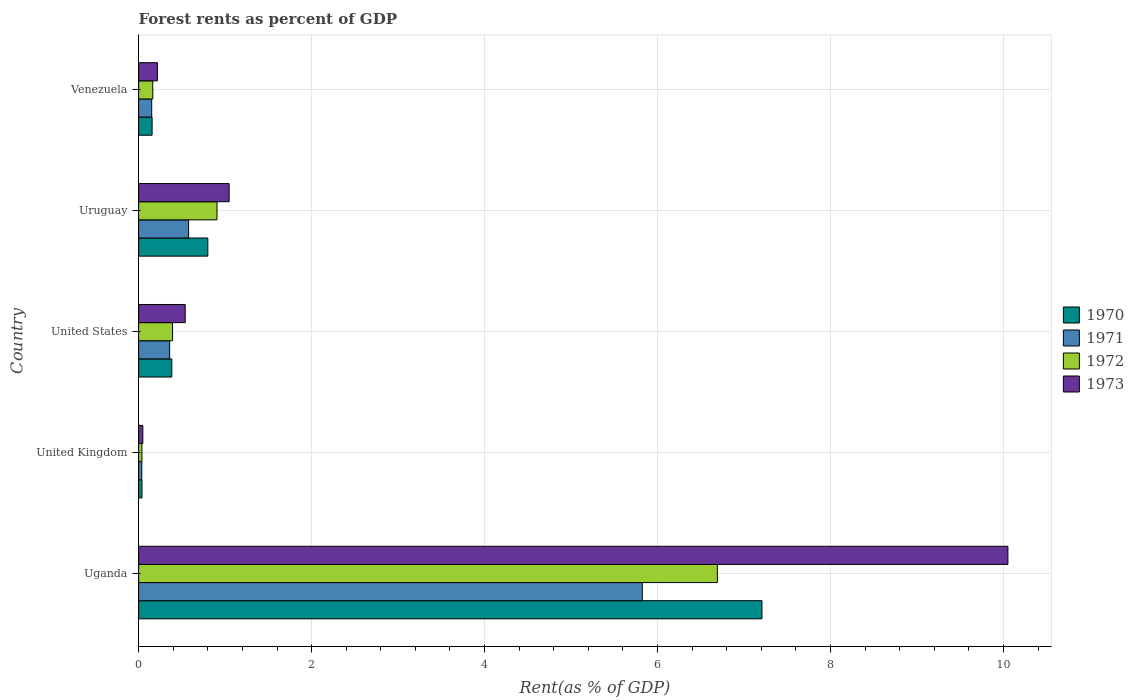How many different coloured bars are there?
Give a very brief answer. 4. Are the number of bars per tick equal to the number of legend labels?
Make the answer very short. Yes. How many bars are there on the 4th tick from the top?
Your response must be concise. 4. What is the label of the 1st group of bars from the top?
Offer a very short reply. Venezuela. What is the forest rent in 1972 in Uganda?
Your answer should be very brief. 6.69. Across all countries, what is the maximum forest rent in 1971?
Provide a short and direct response. 5.82. Across all countries, what is the minimum forest rent in 1970?
Keep it short and to the point. 0.04. In which country was the forest rent in 1973 maximum?
Your answer should be very brief. Uganda. What is the total forest rent in 1973 in the graph?
Provide a short and direct response. 11.9. What is the difference between the forest rent in 1972 in Uganda and that in Venezuela?
Offer a terse response. 6.53. What is the difference between the forest rent in 1970 in United Kingdom and the forest rent in 1971 in Uruguay?
Offer a very short reply. -0.54. What is the average forest rent in 1972 per country?
Your answer should be very brief. 1.64. What is the difference between the forest rent in 1973 and forest rent in 1970 in Uruguay?
Provide a succinct answer. 0.25. In how many countries, is the forest rent in 1970 greater than 8.4 %?
Your answer should be very brief. 0. What is the ratio of the forest rent in 1971 in United States to that in Uruguay?
Keep it short and to the point. 0.62. Is the difference between the forest rent in 1973 in Uruguay and Venezuela greater than the difference between the forest rent in 1970 in Uruguay and Venezuela?
Your response must be concise. Yes. What is the difference between the highest and the second highest forest rent in 1971?
Provide a succinct answer. 5.25. What is the difference between the highest and the lowest forest rent in 1971?
Offer a very short reply. 5.79. In how many countries, is the forest rent in 1970 greater than the average forest rent in 1970 taken over all countries?
Keep it short and to the point. 1. Is the sum of the forest rent in 1971 in United Kingdom and United States greater than the maximum forest rent in 1973 across all countries?
Ensure brevity in your answer.  No. What does the 1st bar from the top in Uruguay represents?
Offer a very short reply. 1973. What does the 1st bar from the bottom in Uganda represents?
Provide a succinct answer. 1970. How many countries are there in the graph?
Provide a short and direct response. 5. What is the difference between two consecutive major ticks on the X-axis?
Your answer should be very brief. 2. Does the graph contain any zero values?
Your answer should be compact. No. Where does the legend appear in the graph?
Ensure brevity in your answer.  Center right. How are the legend labels stacked?
Make the answer very short. Vertical. What is the title of the graph?
Ensure brevity in your answer.  Forest rents as percent of GDP. Does "1970" appear as one of the legend labels in the graph?
Provide a short and direct response. Yes. What is the label or title of the X-axis?
Make the answer very short. Rent(as % of GDP). What is the Rent(as % of GDP) of 1970 in Uganda?
Keep it short and to the point. 7.21. What is the Rent(as % of GDP) of 1971 in Uganda?
Provide a succinct answer. 5.82. What is the Rent(as % of GDP) of 1972 in Uganda?
Your response must be concise. 6.69. What is the Rent(as % of GDP) in 1973 in Uganda?
Provide a short and direct response. 10.05. What is the Rent(as % of GDP) in 1970 in United Kingdom?
Keep it short and to the point. 0.04. What is the Rent(as % of GDP) of 1971 in United Kingdom?
Provide a short and direct response. 0.04. What is the Rent(as % of GDP) in 1972 in United Kingdom?
Make the answer very short. 0.04. What is the Rent(as % of GDP) in 1973 in United Kingdom?
Your answer should be very brief. 0.05. What is the Rent(as % of GDP) in 1970 in United States?
Your answer should be compact. 0.38. What is the Rent(as % of GDP) in 1971 in United States?
Your answer should be very brief. 0.36. What is the Rent(as % of GDP) of 1972 in United States?
Ensure brevity in your answer.  0.39. What is the Rent(as % of GDP) in 1973 in United States?
Provide a succinct answer. 0.54. What is the Rent(as % of GDP) of 1970 in Uruguay?
Provide a succinct answer. 0.8. What is the Rent(as % of GDP) in 1971 in Uruguay?
Your answer should be very brief. 0.58. What is the Rent(as % of GDP) of 1972 in Uruguay?
Give a very brief answer. 0.91. What is the Rent(as % of GDP) in 1973 in Uruguay?
Your answer should be compact. 1.05. What is the Rent(as % of GDP) in 1970 in Venezuela?
Make the answer very short. 0.16. What is the Rent(as % of GDP) in 1971 in Venezuela?
Provide a short and direct response. 0.15. What is the Rent(as % of GDP) of 1972 in Venezuela?
Provide a short and direct response. 0.16. What is the Rent(as % of GDP) of 1973 in Venezuela?
Make the answer very short. 0.22. Across all countries, what is the maximum Rent(as % of GDP) of 1970?
Make the answer very short. 7.21. Across all countries, what is the maximum Rent(as % of GDP) in 1971?
Offer a terse response. 5.82. Across all countries, what is the maximum Rent(as % of GDP) in 1972?
Give a very brief answer. 6.69. Across all countries, what is the maximum Rent(as % of GDP) in 1973?
Your answer should be very brief. 10.05. Across all countries, what is the minimum Rent(as % of GDP) of 1970?
Offer a terse response. 0.04. Across all countries, what is the minimum Rent(as % of GDP) in 1971?
Your response must be concise. 0.04. Across all countries, what is the minimum Rent(as % of GDP) of 1972?
Your response must be concise. 0.04. Across all countries, what is the minimum Rent(as % of GDP) in 1973?
Ensure brevity in your answer.  0.05. What is the total Rent(as % of GDP) in 1970 in the graph?
Your answer should be very brief. 8.59. What is the total Rent(as % of GDP) in 1971 in the graph?
Provide a short and direct response. 6.95. What is the total Rent(as % of GDP) in 1972 in the graph?
Offer a terse response. 8.19. What is the total Rent(as % of GDP) in 1973 in the graph?
Provide a succinct answer. 11.9. What is the difference between the Rent(as % of GDP) in 1970 in Uganda and that in United Kingdom?
Your answer should be compact. 7.17. What is the difference between the Rent(as % of GDP) in 1971 in Uganda and that in United Kingdom?
Keep it short and to the point. 5.79. What is the difference between the Rent(as % of GDP) in 1972 in Uganda and that in United Kingdom?
Provide a succinct answer. 6.65. What is the difference between the Rent(as % of GDP) of 1973 in Uganda and that in United Kingdom?
Your response must be concise. 10. What is the difference between the Rent(as % of GDP) of 1970 in Uganda and that in United States?
Your response must be concise. 6.82. What is the difference between the Rent(as % of GDP) in 1971 in Uganda and that in United States?
Your answer should be very brief. 5.47. What is the difference between the Rent(as % of GDP) of 1972 in Uganda and that in United States?
Your response must be concise. 6.3. What is the difference between the Rent(as % of GDP) in 1973 in Uganda and that in United States?
Offer a very short reply. 9.51. What is the difference between the Rent(as % of GDP) of 1970 in Uganda and that in Uruguay?
Your answer should be very brief. 6.41. What is the difference between the Rent(as % of GDP) in 1971 in Uganda and that in Uruguay?
Ensure brevity in your answer.  5.25. What is the difference between the Rent(as % of GDP) of 1972 in Uganda and that in Uruguay?
Offer a very short reply. 5.79. What is the difference between the Rent(as % of GDP) of 1973 in Uganda and that in Uruguay?
Offer a very short reply. 9. What is the difference between the Rent(as % of GDP) of 1970 in Uganda and that in Venezuela?
Provide a short and direct response. 7.05. What is the difference between the Rent(as % of GDP) in 1971 in Uganda and that in Venezuela?
Provide a short and direct response. 5.67. What is the difference between the Rent(as % of GDP) in 1972 in Uganda and that in Venezuela?
Give a very brief answer. 6.53. What is the difference between the Rent(as % of GDP) of 1973 in Uganda and that in Venezuela?
Keep it short and to the point. 9.83. What is the difference between the Rent(as % of GDP) in 1970 in United Kingdom and that in United States?
Your answer should be compact. -0.34. What is the difference between the Rent(as % of GDP) in 1971 in United Kingdom and that in United States?
Your answer should be very brief. -0.32. What is the difference between the Rent(as % of GDP) in 1972 in United Kingdom and that in United States?
Give a very brief answer. -0.35. What is the difference between the Rent(as % of GDP) in 1973 in United Kingdom and that in United States?
Keep it short and to the point. -0.49. What is the difference between the Rent(as % of GDP) in 1970 in United Kingdom and that in Uruguay?
Ensure brevity in your answer.  -0.76. What is the difference between the Rent(as % of GDP) of 1971 in United Kingdom and that in Uruguay?
Make the answer very short. -0.54. What is the difference between the Rent(as % of GDP) in 1972 in United Kingdom and that in Uruguay?
Offer a terse response. -0.87. What is the difference between the Rent(as % of GDP) in 1973 in United Kingdom and that in Uruguay?
Offer a very short reply. -1. What is the difference between the Rent(as % of GDP) in 1970 in United Kingdom and that in Venezuela?
Offer a very short reply. -0.12. What is the difference between the Rent(as % of GDP) of 1971 in United Kingdom and that in Venezuela?
Ensure brevity in your answer.  -0.11. What is the difference between the Rent(as % of GDP) of 1972 in United Kingdom and that in Venezuela?
Your answer should be very brief. -0.13. What is the difference between the Rent(as % of GDP) of 1973 in United Kingdom and that in Venezuela?
Offer a terse response. -0.17. What is the difference between the Rent(as % of GDP) of 1970 in United States and that in Uruguay?
Ensure brevity in your answer.  -0.42. What is the difference between the Rent(as % of GDP) of 1971 in United States and that in Uruguay?
Your answer should be compact. -0.22. What is the difference between the Rent(as % of GDP) of 1972 in United States and that in Uruguay?
Give a very brief answer. -0.51. What is the difference between the Rent(as % of GDP) of 1973 in United States and that in Uruguay?
Ensure brevity in your answer.  -0.51. What is the difference between the Rent(as % of GDP) of 1970 in United States and that in Venezuela?
Keep it short and to the point. 0.23. What is the difference between the Rent(as % of GDP) of 1971 in United States and that in Venezuela?
Your answer should be compact. 0.21. What is the difference between the Rent(as % of GDP) of 1972 in United States and that in Venezuela?
Provide a short and direct response. 0.23. What is the difference between the Rent(as % of GDP) in 1973 in United States and that in Venezuela?
Your response must be concise. 0.32. What is the difference between the Rent(as % of GDP) of 1970 in Uruguay and that in Venezuela?
Your answer should be very brief. 0.64. What is the difference between the Rent(as % of GDP) in 1971 in Uruguay and that in Venezuela?
Your answer should be compact. 0.43. What is the difference between the Rent(as % of GDP) of 1972 in Uruguay and that in Venezuela?
Give a very brief answer. 0.74. What is the difference between the Rent(as % of GDP) of 1973 in Uruguay and that in Venezuela?
Offer a very short reply. 0.83. What is the difference between the Rent(as % of GDP) in 1970 in Uganda and the Rent(as % of GDP) in 1971 in United Kingdom?
Give a very brief answer. 7.17. What is the difference between the Rent(as % of GDP) in 1970 in Uganda and the Rent(as % of GDP) in 1972 in United Kingdom?
Provide a succinct answer. 7.17. What is the difference between the Rent(as % of GDP) of 1970 in Uganda and the Rent(as % of GDP) of 1973 in United Kingdom?
Make the answer very short. 7.16. What is the difference between the Rent(as % of GDP) of 1971 in Uganda and the Rent(as % of GDP) of 1972 in United Kingdom?
Ensure brevity in your answer.  5.79. What is the difference between the Rent(as % of GDP) of 1971 in Uganda and the Rent(as % of GDP) of 1973 in United Kingdom?
Give a very brief answer. 5.78. What is the difference between the Rent(as % of GDP) of 1972 in Uganda and the Rent(as % of GDP) of 1973 in United Kingdom?
Offer a very short reply. 6.64. What is the difference between the Rent(as % of GDP) of 1970 in Uganda and the Rent(as % of GDP) of 1971 in United States?
Provide a succinct answer. 6.85. What is the difference between the Rent(as % of GDP) of 1970 in Uganda and the Rent(as % of GDP) of 1972 in United States?
Provide a succinct answer. 6.81. What is the difference between the Rent(as % of GDP) of 1970 in Uganda and the Rent(as % of GDP) of 1973 in United States?
Provide a succinct answer. 6.67. What is the difference between the Rent(as % of GDP) of 1971 in Uganda and the Rent(as % of GDP) of 1972 in United States?
Keep it short and to the point. 5.43. What is the difference between the Rent(as % of GDP) in 1971 in Uganda and the Rent(as % of GDP) in 1973 in United States?
Ensure brevity in your answer.  5.29. What is the difference between the Rent(as % of GDP) of 1972 in Uganda and the Rent(as % of GDP) of 1973 in United States?
Provide a short and direct response. 6.15. What is the difference between the Rent(as % of GDP) in 1970 in Uganda and the Rent(as % of GDP) in 1971 in Uruguay?
Give a very brief answer. 6.63. What is the difference between the Rent(as % of GDP) in 1970 in Uganda and the Rent(as % of GDP) in 1972 in Uruguay?
Your answer should be very brief. 6.3. What is the difference between the Rent(as % of GDP) of 1970 in Uganda and the Rent(as % of GDP) of 1973 in Uruguay?
Give a very brief answer. 6.16. What is the difference between the Rent(as % of GDP) in 1971 in Uganda and the Rent(as % of GDP) in 1972 in Uruguay?
Your answer should be very brief. 4.92. What is the difference between the Rent(as % of GDP) in 1971 in Uganda and the Rent(as % of GDP) in 1973 in Uruguay?
Keep it short and to the point. 4.78. What is the difference between the Rent(as % of GDP) of 1972 in Uganda and the Rent(as % of GDP) of 1973 in Uruguay?
Your answer should be compact. 5.65. What is the difference between the Rent(as % of GDP) of 1970 in Uganda and the Rent(as % of GDP) of 1971 in Venezuela?
Your answer should be compact. 7.06. What is the difference between the Rent(as % of GDP) of 1970 in Uganda and the Rent(as % of GDP) of 1972 in Venezuela?
Your answer should be very brief. 7.04. What is the difference between the Rent(as % of GDP) in 1970 in Uganda and the Rent(as % of GDP) in 1973 in Venezuela?
Ensure brevity in your answer.  6.99. What is the difference between the Rent(as % of GDP) of 1971 in Uganda and the Rent(as % of GDP) of 1972 in Venezuela?
Ensure brevity in your answer.  5.66. What is the difference between the Rent(as % of GDP) of 1971 in Uganda and the Rent(as % of GDP) of 1973 in Venezuela?
Keep it short and to the point. 5.61. What is the difference between the Rent(as % of GDP) in 1972 in Uganda and the Rent(as % of GDP) in 1973 in Venezuela?
Give a very brief answer. 6.47. What is the difference between the Rent(as % of GDP) of 1970 in United Kingdom and the Rent(as % of GDP) of 1971 in United States?
Ensure brevity in your answer.  -0.32. What is the difference between the Rent(as % of GDP) of 1970 in United Kingdom and the Rent(as % of GDP) of 1972 in United States?
Make the answer very short. -0.35. What is the difference between the Rent(as % of GDP) of 1970 in United Kingdom and the Rent(as % of GDP) of 1973 in United States?
Your response must be concise. -0.5. What is the difference between the Rent(as % of GDP) in 1971 in United Kingdom and the Rent(as % of GDP) in 1972 in United States?
Your answer should be compact. -0.36. What is the difference between the Rent(as % of GDP) of 1971 in United Kingdom and the Rent(as % of GDP) of 1973 in United States?
Provide a succinct answer. -0.5. What is the difference between the Rent(as % of GDP) in 1972 in United Kingdom and the Rent(as % of GDP) in 1973 in United States?
Provide a succinct answer. -0.5. What is the difference between the Rent(as % of GDP) of 1970 in United Kingdom and the Rent(as % of GDP) of 1971 in Uruguay?
Offer a terse response. -0.54. What is the difference between the Rent(as % of GDP) in 1970 in United Kingdom and the Rent(as % of GDP) in 1972 in Uruguay?
Your response must be concise. -0.87. What is the difference between the Rent(as % of GDP) in 1970 in United Kingdom and the Rent(as % of GDP) in 1973 in Uruguay?
Offer a very short reply. -1.01. What is the difference between the Rent(as % of GDP) in 1971 in United Kingdom and the Rent(as % of GDP) in 1972 in Uruguay?
Your answer should be very brief. -0.87. What is the difference between the Rent(as % of GDP) in 1971 in United Kingdom and the Rent(as % of GDP) in 1973 in Uruguay?
Give a very brief answer. -1.01. What is the difference between the Rent(as % of GDP) in 1972 in United Kingdom and the Rent(as % of GDP) in 1973 in Uruguay?
Provide a short and direct response. -1.01. What is the difference between the Rent(as % of GDP) in 1970 in United Kingdom and the Rent(as % of GDP) in 1971 in Venezuela?
Provide a short and direct response. -0.11. What is the difference between the Rent(as % of GDP) in 1970 in United Kingdom and the Rent(as % of GDP) in 1972 in Venezuela?
Provide a short and direct response. -0.12. What is the difference between the Rent(as % of GDP) of 1970 in United Kingdom and the Rent(as % of GDP) of 1973 in Venezuela?
Offer a very short reply. -0.18. What is the difference between the Rent(as % of GDP) of 1971 in United Kingdom and the Rent(as % of GDP) of 1972 in Venezuela?
Your answer should be very brief. -0.13. What is the difference between the Rent(as % of GDP) in 1971 in United Kingdom and the Rent(as % of GDP) in 1973 in Venezuela?
Keep it short and to the point. -0.18. What is the difference between the Rent(as % of GDP) in 1972 in United Kingdom and the Rent(as % of GDP) in 1973 in Venezuela?
Ensure brevity in your answer.  -0.18. What is the difference between the Rent(as % of GDP) in 1970 in United States and the Rent(as % of GDP) in 1971 in Uruguay?
Provide a succinct answer. -0.19. What is the difference between the Rent(as % of GDP) in 1970 in United States and the Rent(as % of GDP) in 1972 in Uruguay?
Provide a succinct answer. -0.52. What is the difference between the Rent(as % of GDP) of 1970 in United States and the Rent(as % of GDP) of 1973 in Uruguay?
Your answer should be compact. -0.66. What is the difference between the Rent(as % of GDP) of 1971 in United States and the Rent(as % of GDP) of 1972 in Uruguay?
Your answer should be very brief. -0.55. What is the difference between the Rent(as % of GDP) in 1971 in United States and the Rent(as % of GDP) in 1973 in Uruguay?
Provide a succinct answer. -0.69. What is the difference between the Rent(as % of GDP) in 1972 in United States and the Rent(as % of GDP) in 1973 in Uruguay?
Ensure brevity in your answer.  -0.65. What is the difference between the Rent(as % of GDP) in 1970 in United States and the Rent(as % of GDP) in 1971 in Venezuela?
Give a very brief answer. 0.23. What is the difference between the Rent(as % of GDP) in 1970 in United States and the Rent(as % of GDP) in 1972 in Venezuela?
Provide a short and direct response. 0.22. What is the difference between the Rent(as % of GDP) of 1970 in United States and the Rent(as % of GDP) of 1973 in Venezuela?
Offer a terse response. 0.17. What is the difference between the Rent(as % of GDP) of 1971 in United States and the Rent(as % of GDP) of 1972 in Venezuela?
Your answer should be compact. 0.2. What is the difference between the Rent(as % of GDP) of 1971 in United States and the Rent(as % of GDP) of 1973 in Venezuela?
Your response must be concise. 0.14. What is the difference between the Rent(as % of GDP) in 1972 in United States and the Rent(as % of GDP) in 1973 in Venezuela?
Make the answer very short. 0.18. What is the difference between the Rent(as % of GDP) of 1970 in Uruguay and the Rent(as % of GDP) of 1971 in Venezuela?
Keep it short and to the point. 0.65. What is the difference between the Rent(as % of GDP) of 1970 in Uruguay and the Rent(as % of GDP) of 1972 in Venezuela?
Your answer should be very brief. 0.64. What is the difference between the Rent(as % of GDP) in 1970 in Uruguay and the Rent(as % of GDP) in 1973 in Venezuela?
Offer a terse response. 0.58. What is the difference between the Rent(as % of GDP) of 1971 in Uruguay and the Rent(as % of GDP) of 1972 in Venezuela?
Ensure brevity in your answer.  0.41. What is the difference between the Rent(as % of GDP) of 1971 in Uruguay and the Rent(as % of GDP) of 1973 in Venezuela?
Ensure brevity in your answer.  0.36. What is the difference between the Rent(as % of GDP) in 1972 in Uruguay and the Rent(as % of GDP) in 1973 in Venezuela?
Keep it short and to the point. 0.69. What is the average Rent(as % of GDP) in 1970 per country?
Provide a succinct answer. 1.72. What is the average Rent(as % of GDP) in 1971 per country?
Your response must be concise. 1.39. What is the average Rent(as % of GDP) in 1972 per country?
Offer a very short reply. 1.64. What is the average Rent(as % of GDP) of 1973 per country?
Keep it short and to the point. 2.38. What is the difference between the Rent(as % of GDP) in 1970 and Rent(as % of GDP) in 1971 in Uganda?
Provide a short and direct response. 1.38. What is the difference between the Rent(as % of GDP) of 1970 and Rent(as % of GDP) of 1972 in Uganda?
Ensure brevity in your answer.  0.52. What is the difference between the Rent(as % of GDP) in 1970 and Rent(as % of GDP) in 1973 in Uganda?
Keep it short and to the point. -2.84. What is the difference between the Rent(as % of GDP) in 1971 and Rent(as % of GDP) in 1972 in Uganda?
Your response must be concise. -0.87. What is the difference between the Rent(as % of GDP) of 1971 and Rent(as % of GDP) of 1973 in Uganda?
Your response must be concise. -4.23. What is the difference between the Rent(as % of GDP) in 1972 and Rent(as % of GDP) in 1973 in Uganda?
Your response must be concise. -3.36. What is the difference between the Rent(as % of GDP) of 1970 and Rent(as % of GDP) of 1971 in United Kingdom?
Offer a terse response. 0. What is the difference between the Rent(as % of GDP) of 1970 and Rent(as % of GDP) of 1972 in United Kingdom?
Offer a terse response. 0. What is the difference between the Rent(as % of GDP) of 1970 and Rent(as % of GDP) of 1973 in United Kingdom?
Provide a succinct answer. -0.01. What is the difference between the Rent(as % of GDP) in 1971 and Rent(as % of GDP) in 1972 in United Kingdom?
Offer a very short reply. -0. What is the difference between the Rent(as % of GDP) in 1971 and Rent(as % of GDP) in 1973 in United Kingdom?
Offer a very short reply. -0.01. What is the difference between the Rent(as % of GDP) of 1972 and Rent(as % of GDP) of 1973 in United Kingdom?
Keep it short and to the point. -0.01. What is the difference between the Rent(as % of GDP) of 1970 and Rent(as % of GDP) of 1971 in United States?
Make the answer very short. 0.02. What is the difference between the Rent(as % of GDP) in 1970 and Rent(as % of GDP) in 1972 in United States?
Offer a very short reply. -0.01. What is the difference between the Rent(as % of GDP) of 1970 and Rent(as % of GDP) of 1973 in United States?
Provide a succinct answer. -0.16. What is the difference between the Rent(as % of GDP) of 1971 and Rent(as % of GDP) of 1972 in United States?
Your response must be concise. -0.03. What is the difference between the Rent(as % of GDP) of 1971 and Rent(as % of GDP) of 1973 in United States?
Provide a succinct answer. -0.18. What is the difference between the Rent(as % of GDP) in 1972 and Rent(as % of GDP) in 1973 in United States?
Your answer should be very brief. -0.15. What is the difference between the Rent(as % of GDP) in 1970 and Rent(as % of GDP) in 1971 in Uruguay?
Offer a terse response. 0.22. What is the difference between the Rent(as % of GDP) of 1970 and Rent(as % of GDP) of 1972 in Uruguay?
Offer a terse response. -0.11. What is the difference between the Rent(as % of GDP) in 1970 and Rent(as % of GDP) in 1973 in Uruguay?
Offer a very short reply. -0.25. What is the difference between the Rent(as % of GDP) in 1971 and Rent(as % of GDP) in 1972 in Uruguay?
Ensure brevity in your answer.  -0.33. What is the difference between the Rent(as % of GDP) of 1971 and Rent(as % of GDP) of 1973 in Uruguay?
Offer a very short reply. -0.47. What is the difference between the Rent(as % of GDP) in 1972 and Rent(as % of GDP) in 1973 in Uruguay?
Provide a succinct answer. -0.14. What is the difference between the Rent(as % of GDP) of 1970 and Rent(as % of GDP) of 1971 in Venezuela?
Make the answer very short. 0. What is the difference between the Rent(as % of GDP) in 1970 and Rent(as % of GDP) in 1972 in Venezuela?
Provide a short and direct response. -0.01. What is the difference between the Rent(as % of GDP) in 1970 and Rent(as % of GDP) in 1973 in Venezuela?
Make the answer very short. -0.06. What is the difference between the Rent(as % of GDP) in 1971 and Rent(as % of GDP) in 1972 in Venezuela?
Give a very brief answer. -0.01. What is the difference between the Rent(as % of GDP) in 1971 and Rent(as % of GDP) in 1973 in Venezuela?
Make the answer very short. -0.07. What is the difference between the Rent(as % of GDP) in 1972 and Rent(as % of GDP) in 1973 in Venezuela?
Provide a succinct answer. -0.05. What is the ratio of the Rent(as % of GDP) of 1970 in Uganda to that in United Kingdom?
Provide a succinct answer. 184.81. What is the ratio of the Rent(as % of GDP) in 1971 in Uganda to that in United Kingdom?
Your response must be concise. 160.46. What is the ratio of the Rent(as % of GDP) in 1972 in Uganda to that in United Kingdom?
Provide a short and direct response. 175.86. What is the ratio of the Rent(as % of GDP) of 1973 in Uganda to that in United Kingdom?
Your answer should be compact. 206.75. What is the ratio of the Rent(as % of GDP) in 1970 in Uganda to that in United States?
Your answer should be very brief. 18.8. What is the ratio of the Rent(as % of GDP) of 1971 in Uganda to that in United States?
Provide a short and direct response. 16.24. What is the ratio of the Rent(as % of GDP) in 1972 in Uganda to that in United States?
Keep it short and to the point. 17.05. What is the ratio of the Rent(as % of GDP) of 1973 in Uganda to that in United States?
Make the answer very short. 18.66. What is the ratio of the Rent(as % of GDP) of 1970 in Uganda to that in Uruguay?
Provide a succinct answer. 9.01. What is the ratio of the Rent(as % of GDP) of 1971 in Uganda to that in Uruguay?
Your answer should be compact. 10.08. What is the ratio of the Rent(as % of GDP) in 1972 in Uganda to that in Uruguay?
Make the answer very short. 7.38. What is the ratio of the Rent(as % of GDP) of 1973 in Uganda to that in Uruguay?
Keep it short and to the point. 9.6. What is the ratio of the Rent(as % of GDP) of 1970 in Uganda to that in Venezuela?
Keep it short and to the point. 46.24. What is the ratio of the Rent(as % of GDP) of 1971 in Uganda to that in Venezuela?
Make the answer very short. 38.51. What is the ratio of the Rent(as % of GDP) in 1972 in Uganda to that in Venezuela?
Provide a succinct answer. 40.91. What is the ratio of the Rent(as % of GDP) of 1973 in Uganda to that in Venezuela?
Your response must be concise. 46.26. What is the ratio of the Rent(as % of GDP) of 1970 in United Kingdom to that in United States?
Provide a short and direct response. 0.1. What is the ratio of the Rent(as % of GDP) of 1971 in United Kingdom to that in United States?
Ensure brevity in your answer.  0.1. What is the ratio of the Rent(as % of GDP) in 1972 in United Kingdom to that in United States?
Your answer should be very brief. 0.1. What is the ratio of the Rent(as % of GDP) of 1973 in United Kingdom to that in United States?
Ensure brevity in your answer.  0.09. What is the ratio of the Rent(as % of GDP) of 1970 in United Kingdom to that in Uruguay?
Provide a succinct answer. 0.05. What is the ratio of the Rent(as % of GDP) of 1971 in United Kingdom to that in Uruguay?
Your response must be concise. 0.06. What is the ratio of the Rent(as % of GDP) of 1972 in United Kingdom to that in Uruguay?
Keep it short and to the point. 0.04. What is the ratio of the Rent(as % of GDP) of 1973 in United Kingdom to that in Uruguay?
Offer a very short reply. 0.05. What is the ratio of the Rent(as % of GDP) of 1970 in United Kingdom to that in Venezuela?
Provide a short and direct response. 0.25. What is the ratio of the Rent(as % of GDP) of 1971 in United Kingdom to that in Venezuela?
Provide a succinct answer. 0.24. What is the ratio of the Rent(as % of GDP) of 1972 in United Kingdom to that in Venezuela?
Offer a terse response. 0.23. What is the ratio of the Rent(as % of GDP) in 1973 in United Kingdom to that in Venezuela?
Your answer should be very brief. 0.22. What is the ratio of the Rent(as % of GDP) of 1970 in United States to that in Uruguay?
Your response must be concise. 0.48. What is the ratio of the Rent(as % of GDP) in 1971 in United States to that in Uruguay?
Make the answer very short. 0.62. What is the ratio of the Rent(as % of GDP) in 1972 in United States to that in Uruguay?
Ensure brevity in your answer.  0.43. What is the ratio of the Rent(as % of GDP) in 1973 in United States to that in Uruguay?
Provide a succinct answer. 0.51. What is the ratio of the Rent(as % of GDP) in 1970 in United States to that in Venezuela?
Your response must be concise. 2.46. What is the ratio of the Rent(as % of GDP) in 1971 in United States to that in Venezuela?
Offer a terse response. 2.37. What is the ratio of the Rent(as % of GDP) of 1972 in United States to that in Venezuela?
Give a very brief answer. 2.4. What is the ratio of the Rent(as % of GDP) in 1973 in United States to that in Venezuela?
Provide a short and direct response. 2.48. What is the ratio of the Rent(as % of GDP) in 1970 in Uruguay to that in Venezuela?
Offer a terse response. 5.13. What is the ratio of the Rent(as % of GDP) of 1971 in Uruguay to that in Venezuela?
Keep it short and to the point. 3.82. What is the ratio of the Rent(as % of GDP) in 1972 in Uruguay to that in Venezuela?
Your response must be concise. 5.54. What is the ratio of the Rent(as % of GDP) of 1973 in Uruguay to that in Venezuela?
Provide a succinct answer. 4.82. What is the difference between the highest and the second highest Rent(as % of GDP) of 1970?
Provide a short and direct response. 6.41. What is the difference between the highest and the second highest Rent(as % of GDP) in 1971?
Your answer should be compact. 5.25. What is the difference between the highest and the second highest Rent(as % of GDP) in 1972?
Offer a very short reply. 5.79. What is the difference between the highest and the second highest Rent(as % of GDP) of 1973?
Give a very brief answer. 9. What is the difference between the highest and the lowest Rent(as % of GDP) in 1970?
Make the answer very short. 7.17. What is the difference between the highest and the lowest Rent(as % of GDP) in 1971?
Keep it short and to the point. 5.79. What is the difference between the highest and the lowest Rent(as % of GDP) of 1972?
Ensure brevity in your answer.  6.65. What is the difference between the highest and the lowest Rent(as % of GDP) in 1973?
Make the answer very short. 10. 